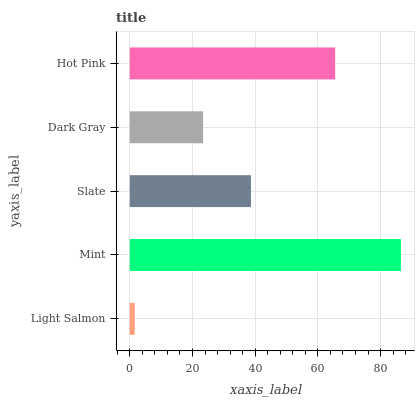Is Light Salmon the minimum?
Answer yes or no. Yes. Is Mint the maximum?
Answer yes or no. Yes. Is Slate the minimum?
Answer yes or no. No. Is Slate the maximum?
Answer yes or no. No. Is Mint greater than Slate?
Answer yes or no. Yes. Is Slate less than Mint?
Answer yes or no. Yes. Is Slate greater than Mint?
Answer yes or no. No. Is Mint less than Slate?
Answer yes or no. No. Is Slate the high median?
Answer yes or no. Yes. Is Slate the low median?
Answer yes or no. Yes. Is Mint the high median?
Answer yes or no. No. Is Mint the low median?
Answer yes or no. No. 